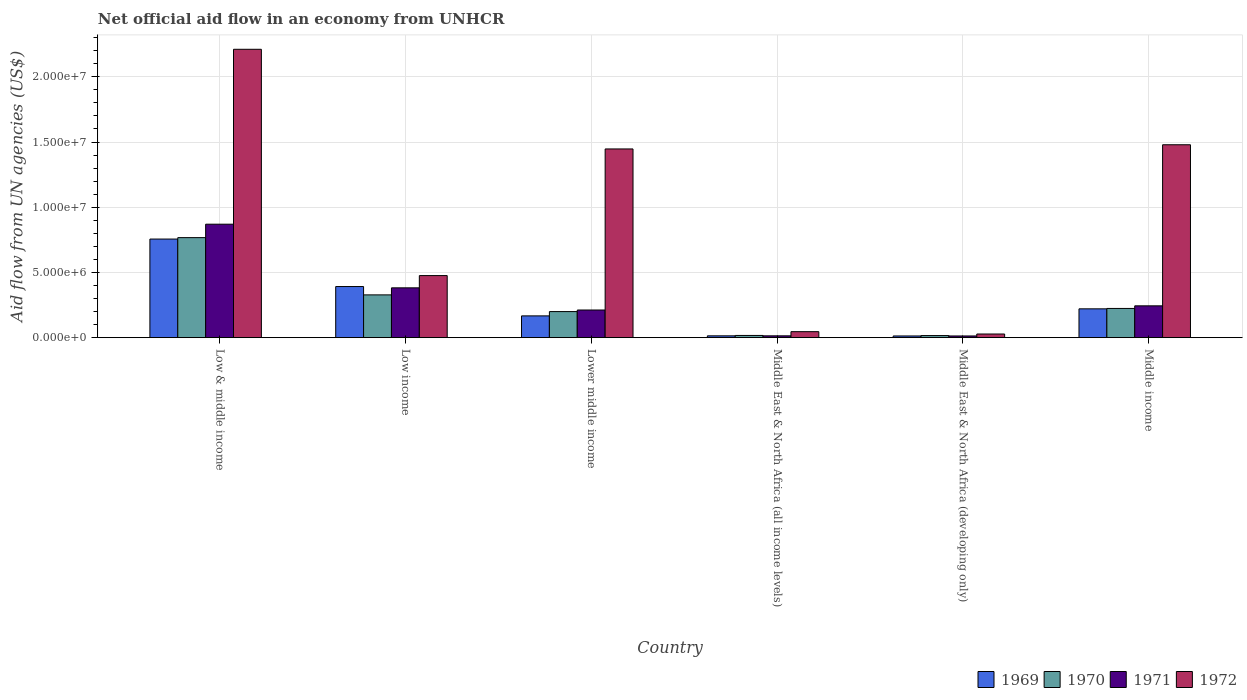How many different coloured bars are there?
Give a very brief answer. 4. Are the number of bars on each tick of the X-axis equal?
Give a very brief answer. Yes. How many bars are there on the 5th tick from the right?
Provide a succinct answer. 4. What is the label of the 4th group of bars from the left?
Make the answer very short. Middle East & North Africa (all income levels). What is the net official aid flow in 1971 in Middle income?
Offer a terse response. 2.44e+06. Across all countries, what is the maximum net official aid flow in 1970?
Your answer should be compact. 7.67e+06. In which country was the net official aid flow in 1971 maximum?
Keep it short and to the point. Low & middle income. In which country was the net official aid flow in 1971 minimum?
Ensure brevity in your answer.  Middle East & North Africa (developing only). What is the total net official aid flow in 1970 in the graph?
Give a very brief answer. 1.55e+07. What is the difference between the net official aid flow in 1970 in Low income and that in Middle income?
Provide a succinct answer. 1.04e+06. What is the difference between the net official aid flow in 1969 in Middle East & North Africa (all income levels) and the net official aid flow in 1970 in Low & middle income?
Provide a succinct answer. -7.53e+06. What is the average net official aid flow in 1971 per country?
Provide a succinct answer. 2.89e+06. In how many countries, is the net official aid flow in 1970 greater than 19000000 US$?
Provide a short and direct response. 0. What is the ratio of the net official aid flow in 1972 in Middle East & North Africa (all income levels) to that in Middle income?
Your answer should be very brief. 0.03. Is the net official aid flow in 1971 in Lower middle income less than that in Middle East & North Africa (developing only)?
Your answer should be compact. No. Is the difference between the net official aid flow in 1971 in Low & middle income and Low income greater than the difference between the net official aid flow in 1969 in Low & middle income and Low income?
Your answer should be very brief. Yes. What is the difference between the highest and the second highest net official aid flow in 1970?
Give a very brief answer. 5.43e+06. What is the difference between the highest and the lowest net official aid flow in 1970?
Keep it short and to the point. 7.51e+06. Is the sum of the net official aid flow in 1972 in Low income and Middle East & North Africa (all income levels) greater than the maximum net official aid flow in 1971 across all countries?
Your response must be concise. No. Is it the case that in every country, the sum of the net official aid flow in 1971 and net official aid flow in 1972 is greater than the net official aid flow in 1969?
Give a very brief answer. Yes. Are all the bars in the graph horizontal?
Give a very brief answer. No. How many countries are there in the graph?
Make the answer very short. 6. What is the difference between two consecutive major ticks on the Y-axis?
Your answer should be very brief. 5.00e+06. Are the values on the major ticks of Y-axis written in scientific E-notation?
Offer a terse response. Yes. Where does the legend appear in the graph?
Ensure brevity in your answer.  Bottom right. How many legend labels are there?
Offer a terse response. 4. How are the legend labels stacked?
Offer a very short reply. Horizontal. What is the title of the graph?
Keep it short and to the point. Net official aid flow in an economy from UNHCR. Does "2013" appear as one of the legend labels in the graph?
Make the answer very short. No. What is the label or title of the X-axis?
Your response must be concise. Country. What is the label or title of the Y-axis?
Keep it short and to the point. Aid flow from UN agencies (US$). What is the Aid flow from UN agencies (US$) in 1969 in Low & middle income?
Your answer should be compact. 7.56e+06. What is the Aid flow from UN agencies (US$) in 1970 in Low & middle income?
Offer a very short reply. 7.67e+06. What is the Aid flow from UN agencies (US$) in 1971 in Low & middle income?
Offer a very short reply. 8.70e+06. What is the Aid flow from UN agencies (US$) in 1972 in Low & middle income?
Offer a terse response. 2.21e+07. What is the Aid flow from UN agencies (US$) in 1969 in Low income?
Keep it short and to the point. 3.92e+06. What is the Aid flow from UN agencies (US$) in 1970 in Low income?
Give a very brief answer. 3.28e+06. What is the Aid flow from UN agencies (US$) in 1971 in Low income?
Keep it short and to the point. 3.82e+06. What is the Aid flow from UN agencies (US$) in 1972 in Low income?
Provide a succinct answer. 4.76e+06. What is the Aid flow from UN agencies (US$) in 1969 in Lower middle income?
Provide a short and direct response. 1.67e+06. What is the Aid flow from UN agencies (US$) of 1971 in Lower middle income?
Provide a short and direct response. 2.12e+06. What is the Aid flow from UN agencies (US$) of 1972 in Lower middle income?
Your answer should be compact. 1.45e+07. What is the Aid flow from UN agencies (US$) of 1969 in Middle income?
Provide a succinct answer. 2.21e+06. What is the Aid flow from UN agencies (US$) of 1970 in Middle income?
Make the answer very short. 2.24e+06. What is the Aid flow from UN agencies (US$) of 1971 in Middle income?
Your response must be concise. 2.44e+06. What is the Aid flow from UN agencies (US$) of 1972 in Middle income?
Offer a terse response. 1.48e+07. Across all countries, what is the maximum Aid flow from UN agencies (US$) of 1969?
Your answer should be compact. 7.56e+06. Across all countries, what is the maximum Aid flow from UN agencies (US$) of 1970?
Your response must be concise. 7.67e+06. Across all countries, what is the maximum Aid flow from UN agencies (US$) of 1971?
Your response must be concise. 8.70e+06. Across all countries, what is the maximum Aid flow from UN agencies (US$) of 1972?
Offer a very short reply. 2.21e+07. Across all countries, what is the minimum Aid flow from UN agencies (US$) in 1970?
Your answer should be very brief. 1.60e+05. Across all countries, what is the minimum Aid flow from UN agencies (US$) of 1972?
Offer a terse response. 2.80e+05. What is the total Aid flow from UN agencies (US$) in 1969 in the graph?
Provide a short and direct response. 1.56e+07. What is the total Aid flow from UN agencies (US$) of 1970 in the graph?
Offer a terse response. 1.55e+07. What is the total Aid flow from UN agencies (US$) in 1971 in the graph?
Provide a short and direct response. 1.74e+07. What is the total Aid flow from UN agencies (US$) in 1972 in the graph?
Make the answer very short. 5.69e+07. What is the difference between the Aid flow from UN agencies (US$) in 1969 in Low & middle income and that in Low income?
Give a very brief answer. 3.64e+06. What is the difference between the Aid flow from UN agencies (US$) of 1970 in Low & middle income and that in Low income?
Provide a succinct answer. 4.39e+06. What is the difference between the Aid flow from UN agencies (US$) of 1971 in Low & middle income and that in Low income?
Your answer should be very brief. 4.88e+06. What is the difference between the Aid flow from UN agencies (US$) of 1972 in Low & middle income and that in Low income?
Offer a terse response. 1.74e+07. What is the difference between the Aid flow from UN agencies (US$) of 1969 in Low & middle income and that in Lower middle income?
Your answer should be very brief. 5.89e+06. What is the difference between the Aid flow from UN agencies (US$) in 1970 in Low & middle income and that in Lower middle income?
Your response must be concise. 5.67e+06. What is the difference between the Aid flow from UN agencies (US$) of 1971 in Low & middle income and that in Lower middle income?
Offer a very short reply. 6.58e+06. What is the difference between the Aid flow from UN agencies (US$) in 1972 in Low & middle income and that in Lower middle income?
Offer a terse response. 7.64e+06. What is the difference between the Aid flow from UN agencies (US$) in 1969 in Low & middle income and that in Middle East & North Africa (all income levels)?
Ensure brevity in your answer.  7.42e+06. What is the difference between the Aid flow from UN agencies (US$) in 1970 in Low & middle income and that in Middle East & North Africa (all income levels)?
Offer a very short reply. 7.50e+06. What is the difference between the Aid flow from UN agencies (US$) in 1971 in Low & middle income and that in Middle East & North Africa (all income levels)?
Offer a terse response. 8.56e+06. What is the difference between the Aid flow from UN agencies (US$) of 1972 in Low & middle income and that in Middle East & North Africa (all income levels)?
Keep it short and to the point. 2.16e+07. What is the difference between the Aid flow from UN agencies (US$) of 1969 in Low & middle income and that in Middle East & North Africa (developing only)?
Give a very brief answer. 7.43e+06. What is the difference between the Aid flow from UN agencies (US$) in 1970 in Low & middle income and that in Middle East & North Africa (developing only)?
Your answer should be very brief. 7.51e+06. What is the difference between the Aid flow from UN agencies (US$) of 1971 in Low & middle income and that in Middle East & North Africa (developing only)?
Ensure brevity in your answer.  8.57e+06. What is the difference between the Aid flow from UN agencies (US$) of 1972 in Low & middle income and that in Middle East & North Africa (developing only)?
Your answer should be compact. 2.18e+07. What is the difference between the Aid flow from UN agencies (US$) of 1969 in Low & middle income and that in Middle income?
Ensure brevity in your answer.  5.35e+06. What is the difference between the Aid flow from UN agencies (US$) in 1970 in Low & middle income and that in Middle income?
Offer a very short reply. 5.43e+06. What is the difference between the Aid flow from UN agencies (US$) in 1971 in Low & middle income and that in Middle income?
Ensure brevity in your answer.  6.26e+06. What is the difference between the Aid flow from UN agencies (US$) of 1972 in Low & middle income and that in Middle income?
Offer a very short reply. 7.32e+06. What is the difference between the Aid flow from UN agencies (US$) of 1969 in Low income and that in Lower middle income?
Make the answer very short. 2.25e+06. What is the difference between the Aid flow from UN agencies (US$) of 1970 in Low income and that in Lower middle income?
Keep it short and to the point. 1.28e+06. What is the difference between the Aid flow from UN agencies (US$) in 1971 in Low income and that in Lower middle income?
Ensure brevity in your answer.  1.70e+06. What is the difference between the Aid flow from UN agencies (US$) of 1972 in Low income and that in Lower middle income?
Offer a very short reply. -9.71e+06. What is the difference between the Aid flow from UN agencies (US$) in 1969 in Low income and that in Middle East & North Africa (all income levels)?
Your response must be concise. 3.78e+06. What is the difference between the Aid flow from UN agencies (US$) of 1970 in Low income and that in Middle East & North Africa (all income levels)?
Offer a terse response. 3.11e+06. What is the difference between the Aid flow from UN agencies (US$) in 1971 in Low income and that in Middle East & North Africa (all income levels)?
Offer a very short reply. 3.68e+06. What is the difference between the Aid flow from UN agencies (US$) of 1972 in Low income and that in Middle East & North Africa (all income levels)?
Provide a short and direct response. 4.30e+06. What is the difference between the Aid flow from UN agencies (US$) in 1969 in Low income and that in Middle East & North Africa (developing only)?
Provide a short and direct response. 3.79e+06. What is the difference between the Aid flow from UN agencies (US$) of 1970 in Low income and that in Middle East & North Africa (developing only)?
Your answer should be very brief. 3.12e+06. What is the difference between the Aid flow from UN agencies (US$) in 1971 in Low income and that in Middle East & North Africa (developing only)?
Your response must be concise. 3.69e+06. What is the difference between the Aid flow from UN agencies (US$) in 1972 in Low income and that in Middle East & North Africa (developing only)?
Your answer should be very brief. 4.48e+06. What is the difference between the Aid flow from UN agencies (US$) of 1969 in Low income and that in Middle income?
Your answer should be compact. 1.71e+06. What is the difference between the Aid flow from UN agencies (US$) in 1970 in Low income and that in Middle income?
Your answer should be very brief. 1.04e+06. What is the difference between the Aid flow from UN agencies (US$) in 1971 in Low income and that in Middle income?
Provide a short and direct response. 1.38e+06. What is the difference between the Aid flow from UN agencies (US$) in 1972 in Low income and that in Middle income?
Your answer should be very brief. -1.00e+07. What is the difference between the Aid flow from UN agencies (US$) in 1969 in Lower middle income and that in Middle East & North Africa (all income levels)?
Offer a terse response. 1.53e+06. What is the difference between the Aid flow from UN agencies (US$) in 1970 in Lower middle income and that in Middle East & North Africa (all income levels)?
Provide a succinct answer. 1.83e+06. What is the difference between the Aid flow from UN agencies (US$) of 1971 in Lower middle income and that in Middle East & North Africa (all income levels)?
Ensure brevity in your answer.  1.98e+06. What is the difference between the Aid flow from UN agencies (US$) in 1972 in Lower middle income and that in Middle East & North Africa (all income levels)?
Your answer should be compact. 1.40e+07. What is the difference between the Aid flow from UN agencies (US$) in 1969 in Lower middle income and that in Middle East & North Africa (developing only)?
Offer a terse response. 1.54e+06. What is the difference between the Aid flow from UN agencies (US$) in 1970 in Lower middle income and that in Middle East & North Africa (developing only)?
Provide a short and direct response. 1.84e+06. What is the difference between the Aid flow from UN agencies (US$) of 1971 in Lower middle income and that in Middle East & North Africa (developing only)?
Your answer should be very brief. 1.99e+06. What is the difference between the Aid flow from UN agencies (US$) in 1972 in Lower middle income and that in Middle East & North Africa (developing only)?
Offer a very short reply. 1.42e+07. What is the difference between the Aid flow from UN agencies (US$) in 1969 in Lower middle income and that in Middle income?
Your answer should be very brief. -5.40e+05. What is the difference between the Aid flow from UN agencies (US$) of 1970 in Lower middle income and that in Middle income?
Your answer should be very brief. -2.40e+05. What is the difference between the Aid flow from UN agencies (US$) in 1971 in Lower middle income and that in Middle income?
Your response must be concise. -3.20e+05. What is the difference between the Aid flow from UN agencies (US$) in 1972 in Lower middle income and that in Middle income?
Provide a short and direct response. -3.20e+05. What is the difference between the Aid flow from UN agencies (US$) in 1970 in Middle East & North Africa (all income levels) and that in Middle East & North Africa (developing only)?
Your answer should be very brief. 10000. What is the difference between the Aid flow from UN agencies (US$) of 1971 in Middle East & North Africa (all income levels) and that in Middle East & North Africa (developing only)?
Give a very brief answer. 10000. What is the difference between the Aid flow from UN agencies (US$) of 1969 in Middle East & North Africa (all income levels) and that in Middle income?
Your answer should be very brief. -2.07e+06. What is the difference between the Aid flow from UN agencies (US$) in 1970 in Middle East & North Africa (all income levels) and that in Middle income?
Offer a terse response. -2.07e+06. What is the difference between the Aid flow from UN agencies (US$) of 1971 in Middle East & North Africa (all income levels) and that in Middle income?
Your answer should be compact. -2.30e+06. What is the difference between the Aid flow from UN agencies (US$) in 1972 in Middle East & North Africa (all income levels) and that in Middle income?
Provide a short and direct response. -1.43e+07. What is the difference between the Aid flow from UN agencies (US$) of 1969 in Middle East & North Africa (developing only) and that in Middle income?
Offer a terse response. -2.08e+06. What is the difference between the Aid flow from UN agencies (US$) of 1970 in Middle East & North Africa (developing only) and that in Middle income?
Offer a very short reply. -2.08e+06. What is the difference between the Aid flow from UN agencies (US$) of 1971 in Middle East & North Africa (developing only) and that in Middle income?
Provide a succinct answer. -2.31e+06. What is the difference between the Aid flow from UN agencies (US$) in 1972 in Middle East & North Africa (developing only) and that in Middle income?
Ensure brevity in your answer.  -1.45e+07. What is the difference between the Aid flow from UN agencies (US$) of 1969 in Low & middle income and the Aid flow from UN agencies (US$) of 1970 in Low income?
Make the answer very short. 4.28e+06. What is the difference between the Aid flow from UN agencies (US$) of 1969 in Low & middle income and the Aid flow from UN agencies (US$) of 1971 in Low income?
Make the answer very short. 3.74e+06. What is the difference between the Aid flow from UN agencies (US$) of 1969 in Low & middle income and the Aid flow from UN agencies (US$) of 1972 in Low income?
Offer a very short reply. 2.80e+06. What is the difference between the Aid flow from UN agencies (US$) of 1970 in Low & middle income and the Aid flow from UN agencies (US$) of 1971 in Low income?
Make the answer very short. 3.85e+06. What is the difference between the Aid flow from UN agencies (US$) of 1970 in Low & middle income and the Aid flow from UN agencies (US$) of 1972 in Low income?
Provide a succinct answer. 2.91e+06. What is the difference between the Aid flow from UN agencies (US$) of 1971 in Low & middle income and the Aid flow from UN agencies (US$) of 1972 in Low income?
Your response must be concise. 3.94e+06. What is the difference between the Aid flow from UN agencies (US$) in 1969 in Low & middle income and the Aid flow from UN agencies (US$) in 1970 in Lower middle income?
Give a very brief answer. 5.56e+06. What is the difference between the Aid flow from UN agencies (US$) in 1969 in Low & middle income and the Aid flow from UN agencies (US$) in 1971 in Lower middle income?
Provide a short and direct response. 5.44e+06. What is the difference between the Aid flow from UN agencies (US$) of 1969 in Low & middle income and the Aid flow from UN agencies (US$) of 1972 in Lower middle income?
Keep it short and to the point. -6.91e+06. What is the difference between the Aid flow from UN agencies (US$) in 1970 in Low & middle income and the Aid flow from UN agencies (US$) in 1971 in Lower middle income?
Offer a very short reply. 5.55e+06. What is the difference between the Aid flow from UN agencies (US$) of 1970 in Low & middle income and the Aid flow from UN agencies (US$) of 1972 in Lower middle income?
Provide a short and direct response. -6.80e+06. What is the difference between the Aid flow from UN agencies (US$) of 1971 in Low & middle income and the Aid flow from UN agencies (US$) of 1972 in Lower middle income?
Keep it short and to the point. -5.77e+06. What is the difference between the Aid flow from UN agencies (US$) of 1969 in Low & middle income and the Aid flow from UN agencies (US$) of 1970 in Middle East & North Africa (all income levels)?
Make the answer very short. 7.39e+06. What is the difference between the Aid flow from UN agencies (US$) of 1969 in Low & middle income and the Aid flow from UN agencies (US$) of 1971 in Middle East & North Africa (all income levels)?
Give a very brief answer. 7.42e+06. What is the difference between the Aid flow from UN agencies (US$) in 1969 in Low & middle income and the Aid flow from UN agencies (US$) in 1972 in Middle East & North Africa (all income levels)?
Your answer should be compact. 7.10e+06. What is the difference between the Aid flow from UN agencies (US$) of 1970 in Low & middle income and the Aid flow from UN agencies (US$) of 1971 in Middle East & North Africa (all income levels)?
Provide a succinct answer. 7.53e+06. What is the difference between the Aid flow from UN agencies (US$) in 1970 in Low & middle income and the Aid flow from UN agencies (US$) in 1972 in Middle East & North Africa (all income levels)?
Your answer should be very brief. 7.21e+06. What is the difference between the Aid flow from UN agencies (US$) in 1971 in Low & middle income and the Aid flow from UN agencies (US$) in 1972 in Middle East & North Africa (all income levels)?
Provide a succinct answer. 8.24e+06. What is the difference between the Aid flow from UN agencies (US$) in 1969 in Low & middle income and the Aid flow from UN agencies (US$) in 1970 in Middle East & North Africa (developing only)?
Give a very brief answer. 7.40e+06. What is the difference between the Aid flow from UN agencies (US$) in 1969 in Low & middle income and the Aid flow from UN agencies (US$) in 1971 in Middle East & North Africa (developing only)?
Provide a succinct answer. 7.43e+06. What is the difference between the Aid flow from UN agencies (US$) in 1969 in Low & middle income and the Aid flow from UN agencies (US$) in 1972 in Middle East & North Africa (developing only)?
Keep it short and to the point. 7.28e+06. What is the difference between the Aid flow from UN agencies (US$) of 1970 in Low & middle income and the Aid flow from UN agencies (US$) of 1971 in Middle East & North Africa (developing only)?
Keep it short and to the point. 7.54e+06. What is the difference between the Aid flow from UN agencies (US$) in 1970 in Low & middle income and the Aid flow from UN agencies (US$) in 1972 in Middle East & North Africa (developing only)?
Your answer should be compact. 7.39e+06. What is the difference between the Aid flow from UN agencies (US$) of 1971 in Low & middle income and the Aid flow from UN agencies (US$) of 1972 in Middle East & North Africa (developing only)?
Ensure brevity in your answer.  8.42e+06. What is the difference between the Aid flow from UN agencies (US$) of 1969 in Low & middle income and the Aid flow from UN agencies (US$) of 1970 in Middle income?
Provide a succinct answer. 5.32e+06. What is the difference between the Aid flow from UN agencies (US$) of 1969 in Low & middle income and the Aid flow from UN agencies (US$) of 1971 in Middle income?
Your response must be concise. 5.12e+06. What is the difference between the Aid flow from UN agencies (US$) in 1969 in Low & middle income and the Aid flow from UN agencies (US$) in 1972 in Middle income?
Keep it short and to the point. -7.23e+06. What is the difference between the Aid flow from UN agencies (US$) of 1970 in Low & middle income and the Aid flow from UN agencies (US$) of 1971 in Middle income?
Your answer should be very brief. 5.23e+06. What is the difference between the Aid flow from UN agencies (US$) in 1970 in Low & middle income and the Aid flow from UN agencies (US$) in 1972 in Middle income?
Offer a terse response. -7.12e+06. What is the difference between the Aid flow from UN agencies (US$) of 1971 in Low & middle income and the Aid flow from UN agencies (US$) of 1972 in Middle income?
Ensure brevity in your answer.  -6.09e+06. What is the difference between the Aid flow from UN agencies (US$) in 1969 in Low income and the Aid flow from UN agencies (US$) in 1970 in Lower middle income?
Give a very brief answer. 1.92e+06. What is the difference between the Aid flow from UN agencies (US$) of 1969 in Low income and the Aid flow from UN agencies (US$) of 1971 in Lower middle income?
Your answer should be very brief. 1.80e+06. What is the difference between the Aid flow from UN agencies (US$) of 1969 in Low income and the Aid flow from UN agencies (US$) of 1972 in Lower middle income?
Offer a very short reply. -1.06e+07. What is the difference between the Aid flow from UN agencies (US$) of 1970 in Low income and the Aid flow from UN agencies (US$) of 1971 in Lower middle income?
Offer a terse response. 1.16e+06. What is the difference between the Aid flow from UN agencies (US$) of 1970 in Low income and the Aid flow from UN agencies (US$) of 1972 in Lower middle income?
Make the answer very short. -1.12e+07. What is the difference between the Aid flow from UN agencies (US$) in 1971 in Low income and the Aid flow from UN agencies (US$) in 1972 in Lower middle income?
Your response must be concise. -1.06e+07. What is the difference between the Aid flow from UN agencies (US$) of 1969 in Low income and the Aid flow from UN agencies (US$) of 1970 in Middle East & North Africa (all income levels)?
Keep it short and to the point. 3.75e+06. What is the difference between the Aid flow from UN agencies (US$) in 1969 in Low income and the Aid flow from UN agencies (US$) in 1971 in Middle East & North Africa (all income levels)?
Provide a succinct answer. 3.78e+06. What is the difference between the Aid flow from UN agencies (US$) of 1969 in Low income and the Aid flow from UN agencies (US$) of 1972 in Middle East & North Africa (all income levels)?
Offer a terse response. 3.46e+06. What is the difference between the Aid flow from UN agencies (US$) of 1970 in Low income and the Aid flow from UN agencies (US$) of 1971 in Middle East & North Africa (all income levels)?
Ensure brevity in your answer.  3.14e+06. What is the difference between the Aid flow from UN agencies (US$) in 1970 in Low income and the Aid flow from UN agencies (US$) in 1972 in Middle East & North Africa (all income levels)?
Offer a very short reply. 2.82e+06. What is the difference between the Aid flow from UN agencies (US$) in 1971 in Low income and the Aid flow from UN agencies (US$) in 1972 in Middle East & North Africa (all income levels)?
Offer a terse response. 3.36e+06. What is the difference between the Aid flow from UN agencies (US$) of 1969 in Low income and the Aid flow from UN agencies (US$) of 1970 in Middle East & North Africa (developing only)?
Your answer should be very brief. 3.76e+06. What is the difference between the Aid flow from UN agencies (US$) of 1969 in Low income and the Aid flow from UN agencies (US$) of 1971 in Middle East & North Africa (developing only)?
Keep it short and to the point. 3.79e+06. What is the difference between the Aid flow from UN agencies (US$) of 1969 in Low income and the Aid flow from UN agencies (US$) of 1972 in Middle East & North Africa (developing only)?
Offer a very short reply. 3.64e+06. What is the difference between the Aid flow from UN agencies (US$) in 1970 in Low income and the Aid flow from UN agencies (US$) in 1971 in Middle East & North Africa (developing only)?
Provide a short and direct response. 3.15e+06. What is the difference between the Aid flow from UN agencies (US$) in 1971 in Low income and the Aid flow from UN agencies (US$) in 1972 in Middle East & North Africa (developing only)?
Make the answer very short. 3.54e+06. What is the difference between the Aid flow from UN agencies (US$) in 1969 in Low income and the Aid flow from UN agencies (US$) in 1970 in Middle income?
Your answer should be very brief. 1.68e+06. What is the difference between the Aid flow from UN agencies (US$) in 1969 in Low income and the Aid flow from UN agencies (US$) in 1971 in Middle income?
Provide a succinct answer. 1.48e+06. What is the difference between the Aid flow from UN agencies (US$) in 1969 in Low income and the Aid flow from UN agencies (US$) in 1972 in Middle income?
Ensure brevity in your answer.  -1.09e+07. What is the difference between the Aid flow from UN agencies (US$) of 1970 in Low income and the Aid flow from UN agencies (US$) of 1971 in Middle income?
Give a very brief answer. 8.40e+05. What is the difference between the Aid flow from UN agencies (US$) in 1970 in Low income and the Aid flow from UN agencies (US$) in 1972 in Middle income?
Offer a terse response. -1.15e+07. What is the difference between the Aid flow from UN agencies (US$) in 1971 in Low income and the Aid flow from UN agencies (US$) in 1972 in Middle income?
Offer a terse response. -1.10e+07. What is the difference between the Aid flow from UN agencies (US$) of 1969 in Lower middle income and the Aid flow from UN agencies (US$) of 1970 in Middle East & North Africa (all income levels)?
Your answer should be very brief. 1.50e+06. What is the difference between the Aid flow from UN agencies (US$) of 1969 in Lower middle income and the Aid flow from UN agencies (US$) of 1971 in Middle East & North Africa (all income levels)?
Your response must be concise. 1.53e+06. What is the difference between the Aid flow from UN agencies (US$) of 1969 in Lower middle income and the Aid flow from UN agencies (US$) of 1972 in Middle East & North Africa (all income levels)?
Offer a terse response. 1.21e+06. What is the difference between the Aid flow from UN agencies (US$) in 1970 in Lower middle income and the Aid flow from UN agencies (US$) in 1971 in Middle East & North Africa (all income levels)?
Your answer should be compact. 1.86e+06. What is the difference between the Aid flow from UN agencies (US$) in 1970 in Lower middle income and the Aid flow from UN agencies (US$) in 1972 in Middle East & North Africa (all income levels)?
Keep it short and to the point. 1.54e+06. What is the difference between the Aid flow from UN agencies (US$) of 1971 in Lower middle income and the Aid flow from UN agencies (US$) of 1972 in Middle East & North Africa (all income levels)?
Offer a terse response. 1.66e+06. What is the difference between the Aid flow from UN agencies (US$) in 1969 in Lower middle income and the Aid flow from UN agencies (US$) in 1970 in Middle East & North Africa (developing only)?
Provide a short and direct response. 1.51e+06. What is the difference between the Aid flow from UN agencies (US$) of 1969 in Lower middle income and the Aid flow from UN agencies (US$) of 1971 in Middle East & North Africa (developing only)?
Your response must be concise. 1.54e+06. What is the difference between the Aid flow from UN agencies (US$) in 1969 in Lower middle income and the Aid flow from UN agencies (US$) in 1972 in Middle East & North Africa (developing only)?
Provide a succinct answer. 1.39e+06. What is the difference between the Aid flow from UN agencies (US$) in 1970 in Lower middle income and the Aid flow from UN agencies (US$) in 1971 in Middle East & North Africa (developing only)?
Your answer should be very brief. 1.87e+06. What is the difference between the Aid flow from UN agencies (US$) of 1970 in Lower middle income and the Aid flow from UN agencies (US$) of 1972 in Middle East & North Africa (developing only)?
Your answer should be very brief. 1.72e+06. What is the difference between the Aid flow from UN agencies (US$) in 1971 in Lower middle income and the Aid flow from UN agencies (US$) in 1972 in Middle East & North Africa (developing only)?
Provide a short and direct response. 1.84e+06. What is the difference between the Aid flow from UN agencies (US$) in 1969 in Lower middle income and the Aid flow from UN agencies (US$) in 1970 in Middle income?
Make the answer very short. -5.70e+05. What is the difference between the Aid flow from UN agencies (US$) of 1969 in Lower middle income and the Aid flow from UN agencies (US$) of 1971 in Middle income?
Provide a succinct answer. -7.70e+05. What is the difference between the Aid flow from UN agencies (US$) in 1969 in Lower middle income and the Aid flow from UN agencies (US$) in 1972 in Middle income?
Provide a succinct answer. -1.31e+07. What is the difference between the Aid flow from UN agencies (US$) in 1970 in Lower middle income and the Aid flow from UN agencies (US$) in 1971 in Middle income?
Provide a short and direct response. -4.40e+05. What is the difference between the Aid flow from UN agencies (US$) of 1970 in Lower middle income and the Aid flow from UN agencies (US$) of 1972 in Middle income?
Give a very brief answer. -1.28e+07. What is the difference between the Aid flow from UN agencies (US$) of 1971 in Lower middle income and the Aid flow from UN agencies (US$) of 1972 in Middle income?
Give a very brief answer. -1.27e+07. What is the difference between the Aid flow from UN agencies (US$) in 1969 in Middle East & North Africa (all income levels) and the Aid flow from UN agencies (US$) in 1972 in Middle East & North Africa (developing only)?
Make the answer very short. -1.40e+05. What is the difference between the Aid flow from UN agencies (US$) of 1969 in Middle East & North Africa (all income levels) and the Aid flow from UN agencies (US$) of 1970 in Middle income?
Make the answer very short. -2.10e+06. What is the difference between the Aid flow from UN agencies (US$) in 1969 in Middle East & North Africa (all income levels) and the Aid flow from UN agencies (US$) in 1971 in Middle income?
Your answer should be very brief. -2.30e+06. What is the difference between the Aid flow from UN agencies (US$) in 1969 in Middle East & North Africa (all income levels) and the Aid flow from UN agencies (US$) in 1972 in Middle income?
Offer a terse response. -1.46e+07. What is the difference between the Aid flow from UN agencies (US$) of 1970 in Middle East & North Africa (all income levels) and the Aid flow from UN agencies (US$) of 1971 in Middle income?
Make the answer very short. -2.27e+06. What is the difference between the Aid flow from UN agencies (US$) in 1970 in Middle East & North Africa (all income levels) and the Aid flow from UN agencies (US$) in 1972 in Middle income?
Your response must be concise. -1.46e+07. What is the difference between the Aid flow from UN agencies (US$) of 1971 in Middle East & North Africa (all income levels) and the Aid flow from UN agencies (US$) of 1972 in Middle income?
Keep it short and to the point. -1.46e+07. What is the difference between the Aid flow from UN agencies (US$) of 1969 in Middle East & North Africa (developing only) and the Aid flow from UN agencies (US$) of 1970 in Middle income?
Keep it short and to the point. -2.11e+06. What is the difference between the Aid flow from UN agencies (US$) of 1969 in Middle East & North Africa (developing only) and the Aid flow from UN agencies (US$) of 1971 in Middle income?
Offer a very short reply. -2.31e+06. What is the difference between the Aid flow from UN agencies (US$) of 1969 in Middle East & North Africa (developing only) and the Aid flow from UN agencies (US$) of 1972 in Middle income?
Provide a succinct answer. -1.47e+07. What is the difference between the Aid flow from UN agencies (US$) in 1970 in Middle East & North Africa (developing only) and the Aid flow from UN agencies (US$) in 1971 in Middle income?
Give a very brief answer. -2.28e+06. What is the difference between the Aid flow from UN agencies (US$) of 1970 in Middle East & North Africa (developing only) and the Aid flow from UN agencies (US$) of 1972 in Middle income?
Offer a terse response. -1.46e+07. What is the difference between the Aid flow from UN agencies (US$) of 1971 in Middle East & North Africa (developing only) and the Aid flow from UN agencies (US$) of 1972 in Middle income?
Offer a terse response. -1.47e+07. What is the average Aid flow from UN agencies (US$) in 1969 per country?
Ensure brevity in your answer.  2.60e+06. What is the average Aid flow from UN agencies (US$) in 1970 per country?
Give a very brief answer. 2.59e+06. What is the average Aid flow from UN agencies (US$) in 1971 per country?
Keep it short and to the point. 2.89e+06. What is the average Aid flow from UN agencies (US$) of 1972 per country?
Offer a terse response. 9.48e+06. What is the difference between the Aid flow from UN agencies (US$) in 1969 and Aid flow from UN agencies (US$) in 1970 in Low & middle income?
Keep it short and to the point. -1.10e+05. What is the difference between the Aid flow from UN agencies (US$) of 1969 and Aid flow from UN agencies (US$) of 1971 in Low & middle income?
Keep it short and to the point. -1.14e+06. What is the difference between the Aid flow from UN agencies (US$) of 1969 and Aid flow from UN agencies (US$) of 1972 in Low & middle income?
Ensure brevity in your answer.  -1.46e+07. What is the difference between the Aid flow from UN agencies (US$) of 1970 and Aid flow from UN agencies (US$) of 1971 in Low & middle income?
Your response must be concise. -1.03e+06. What is the difference between the Aid flow from UN agencies (US$) in 1970 and Aid flow from UN agencies (US$) in 1972 in Low & middle income?
Your answer should be compact. -1.44e+07. What is the difference between the Aid flow from UN agencies (US$) of 1971 and Aid flow from UN agencies (US$) of 1972 in Low & middle income?
Keep it short and to the point. -1.34e+07. What is the difference between the Aid flow from UN agencies (US$) of 1969 and Aid flow from UN agencies (US$) of 1970 in Low income?
Give a very brief answer. 6.40e+05. What is the difference between the Aid flow from UN agencies (US$) in 1969 and Aid flow from UN agencies (US$) in 1972 in Low income?
Keep it short and to the point. -8.40e+05. What is the difference between the Aid flow from UN agencies (US$) of 1970 and Aid flow from UN agencies (US$) of 1971 in Low income?
Provide a succinct answer. -5.40e+05. What is the difference between the Aid flow from UN agencies (US$) of 1970 and Aid flow from UN agencies (US$) of 1972 in Low income?
Give a very brief answer. -1.48e+06. What is the difference between the Aid flow from UN agencies (US$) of 1971 and Aid flow from UN agencies (US$) of 1972 in Low income?
Offer a terse response. -9.40e+05. What is the difference between the Aid flow from UN agencies (US$) in 1969 and Aid flow from UN agencies (US$) in 1970 in Lower middle income?
Your response must be concise. -3.30e+05. What is the difference between the Aid flow from UN agencies (US$) in 1969 and Aid flow from UN agencies (US$) in 1971 in Lower middle income?
Ensure brevity in your answer.  -4.50e+05. What is the difference between the Aid flow from UN agencies (US$) in 1969 and Aid flow from UN agencies (US$) in 1972 in Lower middle income?
Provide a short and direct response. -1.28e+07. What is the difference between the Aid flow from UN agencies (US$) in 1970 and Aid flow from UN agencies (US$) in 1971 in Lower middle income?
Ensure brevity in your answer.  -1.20e+05. What is the difference between the Aid flow from UN agencies (US$) in 1970 and Aid flow from UN agencies (US$) in 1972 in Lower middle income?
Make the answer very short. -1.25e+07. What is the difference between the Aid flow from UN agencies (US$) in 1971 and Aid flow from UN agencies (US$) in 1972 in Lower middle income?
Your response must be concise. -1.24e+07. What is the difference between the Aid flow from UN agencies (US$) in 1969 and Aid flow from UN agencies (US$) in 1971 in Middle East & North Africa (all income levels)?
Keep it short and to the point. 0. What is the difference between the Aid flow from UN agencies (US$) of 1969 and Aid flow from UN agencies (US$) of 1972 in Middle East & North Africa (all income levels)?
Provide a short and direct response. -3.20e+05. What is the difference between the Aid flow from UN agencies (US$) in 1971 and Aid flow from UN agencies (US$) in 1972 in Middle East & North Africa (all income levels)?
Your answer should be very brief. -3.20e+05. What is the difference between the Aid flow from UN agencies (US$) of 1969 and Aid flow from UN agencies (US$) of 1971 in Middle East & North Africa (developing only)?
Ensure brevity in your answer.  0. What is the difference between the Aid flow from UN agencies (US$) of 1970 and Aid flow from UN agencies (US$) of 1971 in Middle East & North Africa (developing only)?
Offer a very short reply. 3.00e+04. What is the difference between the Aid flow from UN agencies (US$) in 1970 and Aid flow from UN agencies (US$) in 1972 in Middle East & North Africa (developing only)?
Offer a very short reply. -1.20e+05. What is the difference between the Aid flow from UN agencies (US$) in 1971 and Aid flow from UN agencies (US$) in 1972 in Middle East & North Africa (developing only)?
Offer a very short reply. -1.50e+05. What is the difference between the Aid flow from UN agencies (US$) of 1969 and Aid flow from UN agencies (US$) of 1971 in Middle income?
Offer a very short reply. -2.30e+05. What is the difference between the Aid flow from UN agencies (US$) of 1969 and Aid flow from UN agencies (US$) of 1972 in Middle income?
Provide a succinct answer. -1.26e+07. What is the difference between the Aid flow from UN agencies (US$) of 1970 and Aid flow from UN agencies (US$) of 1972 in Middle income?
Ensure brevity in your answer.  -1.26e+07. What is the difference between the Aid flow from UN agencies (US$) of 1971 and Aid flow from UN agencies (US$) of 1972 in Middle income?
Give a very brief answer. -1.24e+07. What is the ratio of the Aid flow from UN agencies (US$) in 1969 in Low & middle income to that in Low income?
Make the answer very short. 1.93. What is the ratio of the Aid flow from UN agencies (US$) of 1970 in Low & middle income to that in Low income?
Provide a short and direct response. 2.34. What is the ratio of the Aid flow from UN agencies (US$) of 1971 in Low & middle income to that in Low income?
Provide a succinct answer. 2.28. What is the ratio of the Aid flow from UN agencies (US$) in 1972 in Low & middle income to that in Low income?
Your answer should be very brief. 4.64. What is the ratio of the Aid flow from UN agencies (US$) of 1969 in Low & middle income to that in Lower middle income?
Keep it short and to the point. 4.53. What is the ratio of the Aid flow from UN agencies (US$) of 1970 in Low & middle income to that in Lower middle income?
Make the answer very short. 3.83. What is the ratio of the Aid flow from UN agencies (US$) in 1971 in Low & middle income to that in Lower middle income?
Keep it short and to the point. 4.1. What is the ratio of the Aid flow from UN agencies (US$) of 1972 in Low & middle income to that in Lower middle income?
Provide a succinct answer. 1.53. What is the ratio of the Aid flow from UN agencies (US$) in 1970 in Low & middle income to that in Middle East & North Africa (all income levels)?
Give a very brief answer. 45.12. What is the ratio of the Aid flow from UN agencies (US$) of 1971 in Low & middle income to that in Middle East & North Africa (all income levels)?
Your response must be concise. 62.14. What is the ratio of the Aid flow from UN agencies (US$) in 1972 in Low & middle income to that in Middle East & North Africa (all income levels)?
Ensure brevity in your answer.  48.07. What is the ratio of the Aid flow from UN agencies (US$) in 1969 in Low & middle income to that in Middle East & North Africa (developing only)?
Your answer should be compact. 58.15. What is the ratio of the Aid flow from UN agencies (US$) of 1970 in Low & middle income to that in Middle East & North Africa (developing only)?
Offer a very short reply. 47.94. What is the ratio of the Aid flow from UN agencies (US$) of 1971 in Low & middle income to that in Middle East & North Africa (developing only)?
Make the answer very short. 66.92. What is the ratio of the Aid flow from UN agencies (US$) in 1972 in Low & middle income to that in Middle East & North Africa (developing only)?
Ensure brevity in your answer.  78.96. What is the ratio of the Aid flow from UN agencies (US$) in 1969 in Low & middle income to that in Middle income?
Provide a short and direct response. 3.42. What is the ratio of the Aid flow from UN agencies (US$) of 1970 in Low & middle income to that in Middle income?
Give a very brief answer. 3.42. What is the ratio of the Aid flow from UN agencies (US$) in 1971 in Low & middle income to that in Middle income?
Make the answer very short. 3.57. What is the ratio of the Aid flow from UN agencies (US$) in 1972 in Low & middle income to that in Middle income?
Offer a very short reply. 1.49. What is the ratio of the Aid flow from UN agencies (US$) of 1969 in Low income to that in Lower middle income?
Your answer should be compact. 2.35. What is the ratio of the Aid flow from UN agencies (US$) of 1970 in Low income to that in Lower middle income?
Give a very brief answer. 1.64. What is the ratio of the Aid flow from UN agencies (US$) of 1971 in Low income to that in Lower middle income?
Offer a terse response. 1.8. What is the ratio of the Aid flow from UN agencies (US$) in 1972 in Low income to that in Lower middle income?
Offer a very short reply. 0.33. What is the ratio of the Aid flow from UN agencies (US$) of 1969 in Low income to that in Middle East & North Africa (all income levels)?
Give a very brief answer. 28. What is the ratio of the Aid flow from UN agencies (US$) of 1970 in Low income to that in Middle East & North Africa (all income levels)?
Make the answer very short. 19.29. What is the ratio of the Aid flow from UN agencies (US$) of 1971 in Low income to that in Middle East & North Africa (all income levels)?
Make the answer very short. 27.29. What is the ratio of the Aid flow from UN agencies (US$) in 1972 in Low income to that in Middle East & North Africa (all income levels)?
Make the answer very short. 10.35. What is the ratio of the Aid flow from UN agencies (US$) in 1969 in Low income to that in Middle East & North Africa (developing only)?
Offer a terse response. 30.15. What is the ratio of the Aid flow from UN agencies (US$) in 1971 in Low income to that in Middle East & North Africa (developing only)?
Keep it short and to the point. 29.38. What is the ratio of the Aid flow from UN agencies (US$) of 1969 in Low income to that in Middle income?
Offer a terse response. 1.77. What is the ratio of the Aid flow from UN agencies (US$) in 1970 in Low income to that in Middle income?
Keep it short and to the point. 1.46. What is the ratio of the Aid flow from UN agencies (US$) in 1971 in Low income to that in Middle income?
Your answer should be compact. 1.57. What is the ratio of the Aid flow from UN agencies (US$) of 1972 in Low income to that in Middle income?
Keep it short and to the point. 0.32. What is the ratio of the Aid flow from UN agencies (US$) of 1969 in Lower middle income to that in Middle East & North Africa (all income levels)?
Your answer should be very brief. 11.93. What is the ratio of the Aid flow from UN agencies (US$) of 1970 in Lower middle income to that in Middle East & North Africa (all income levels)?
Provide a short and direct response. 11.76. What is the ratio of the Aid flow from UN agencies (US$) of 1971 in Lower middle income to that in Middle East & North Africa (all income levels)?
Keep it short and to the point. 15.14. What is the ratio of the Aid flow from UN agencies (US$) in 1972 in Lower middle income to that in Middle East & North Africa (all income levels)?
Offer a very short reply. 31.46. What is the ratio of the Aid flow from UN agencies (US$) of 1969 in Lower middle income to that in Middle East & North Africa (developing only)?
Ensure brevity in your answer.  12.85. What is the ratio of the Aid flow from UN agencies (US$) in 1971 in Lower middle income to that in Middle East & North Africa (developing only)?
Offer a very short reply. 16.31. What is the ratio of the Aid flow from UN agencies (US$) in 1972 in Lower middle income to that in Middle East & North Africa (developing only)?
Keep it short and to the point. 51.68. What is the ratio of the Aid flow from UN agencies (US$) of 1969 in Lower middle income to that in Middle income?
Make the answer very short. 0.76. What is the ratio of the Aid flow from UN agencies (US$) in 1970 in Lower middle income to that in Middle income?
Offer a very short reply. 0.89. What is the ratio of the Aid flow from UN agencies (US$) in 1971 in Lower middle income to that in Middle income?
Provide a succinct answer. 0.87. What is the ratio of the Aid flow from UN agencies (US$) in 1972 in Lower middle income to that in Middle income?
Your response must be concise. 0.98. What is the ratio of the Aid flow from UN agencies (US$) in 1969 in Middle East & North Africa (all income levels) to that in Middle East & North Africa (developing only)?
Offer a very short reply. 1.08. What is the ratio of the Aid flow from UN agencies (US$) of 1970 in Middle East & North Africa (all income levels) to that in Middle East & North Africa (developing only)?
Your answer should be compact. 1.06. What is the ratio of the Aid flow from UN agencies (US$) of 1972 in Middle East & North Africa (all income levels) to that in Middle East & North Africa (developing only)?
Make the answer very short. 1.64. What is the ratio of the Aid flow from UN agencies (US$) in 1969 in Middle East & North Africa (all income levels) to that in Middle income?
Ensure brevity in your answer.  0.06. What is the ratio of the Aid flow from UN agencies (US$) in 1970 in Middle East & North Africa (all income levels) to that in Middle income?
Offer a very short reply. 0.08. What is the ratio of the Aid flow from UN agencies (US$) in 1971 in Middle East & North Africa (all income levels) to that in Middle income?
Give a very brief answer. 0.06. What is the ratio of the Aid flow from UN agencies (US$) in 1972 in Middle East & North Africa (all income levels) to that in Middle income?
Provide a succinct answer. 0.03. What is the ratio of the Aid flow from UN agencies (US$) in 1969 in Middle East & North Africa (developing only) to that in Middle income?
Your answer should be compact. 0.06. What is the ratio of the Aid flow from UN agencies (US$) of 1970 in Middle East & North Africa (developing only) to that in Middle income?
Offer a terse response. 0.07. What is the ratio of the Aid flow from UN agencies (US$) in 1971 in Middle East & North Africa (developing only) to that in Middle income?
Provide a short and direct response. 0.05. What is the ratio of the Aid flow from UN agencies (US$) in 1972 in Middle East & North Africa (developing only) to that in Middle income?
Your answer should be very brief. 0.02. What is the difference between the highest and the second highest Aid flow from UN agencies (US$) in 1969?
Provide a succinct answer. 3.64e+06. What is the difference between the highest and the second highest Aid flow from UN agencies (US$) of 1970?
Ensure brevity in your answer.  4.39e+06. What is the difference between the highest and the second highest Aid flow from UN agencies (US$) of 1971?
Give a very brief answer. 4.88e+06. What is the difference between the highest and the second highest Aid flow from UN agencies (US$) in 1972?
Keep it short and to the point. 7.32e+06. What is the difference between the highest and the lowest Aid flow from UN agencies (US$) in 1969?
Provide a succinct answer. 7.43e+06. What is the difference between the highest and the lowest Aid flow from UN agencies (US$) of 1970?
Offer a terse response. 7.51e+06. What is the difference between the highest and the lowest Aid flow from UN agencies (US$) in 1971?
Your response must be concise. 8.57e+06. What is the difference between the highest and the lowest Aid flow from UN agencies (US$) of 1972?
Offer a terse response. 2.18e+07. 